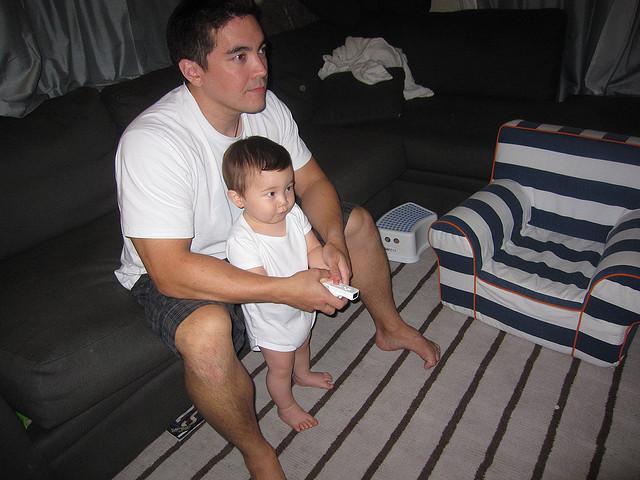How many people are in the picture?
Give a very brief answer. 2. How many chairs don't have a dog on them?
Give a very brief answer. 0. 